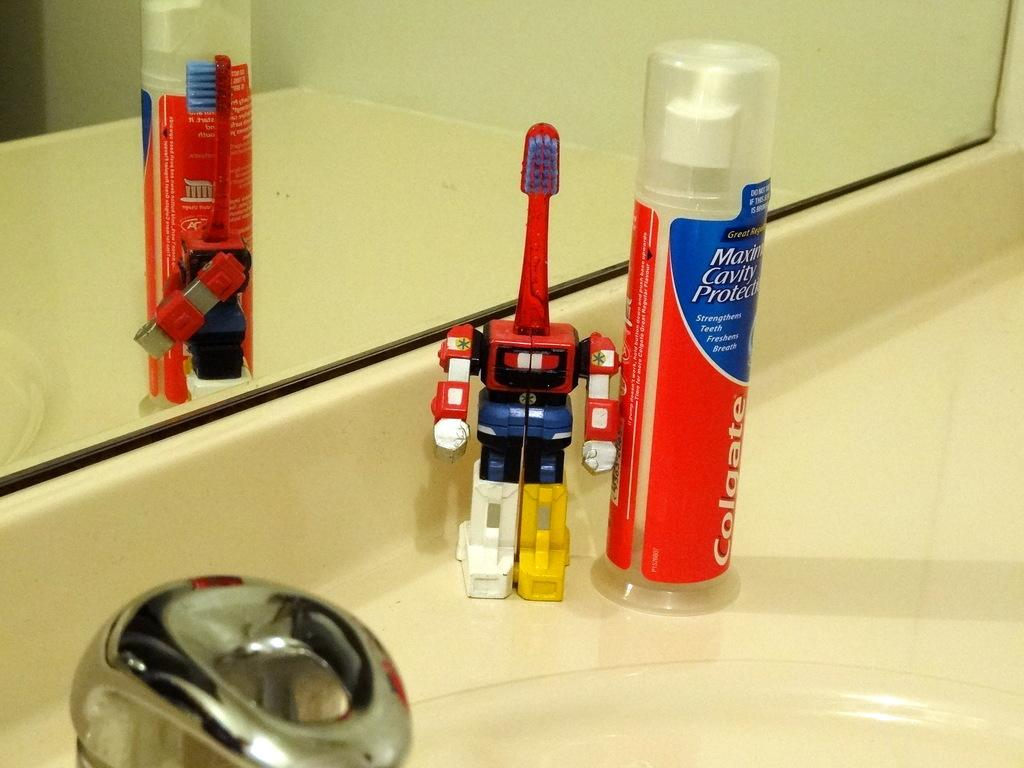<image>
Give a short and clear explanation of the subsequent image. A robot toothpaste and Colgate toothpaste are on the sink. 